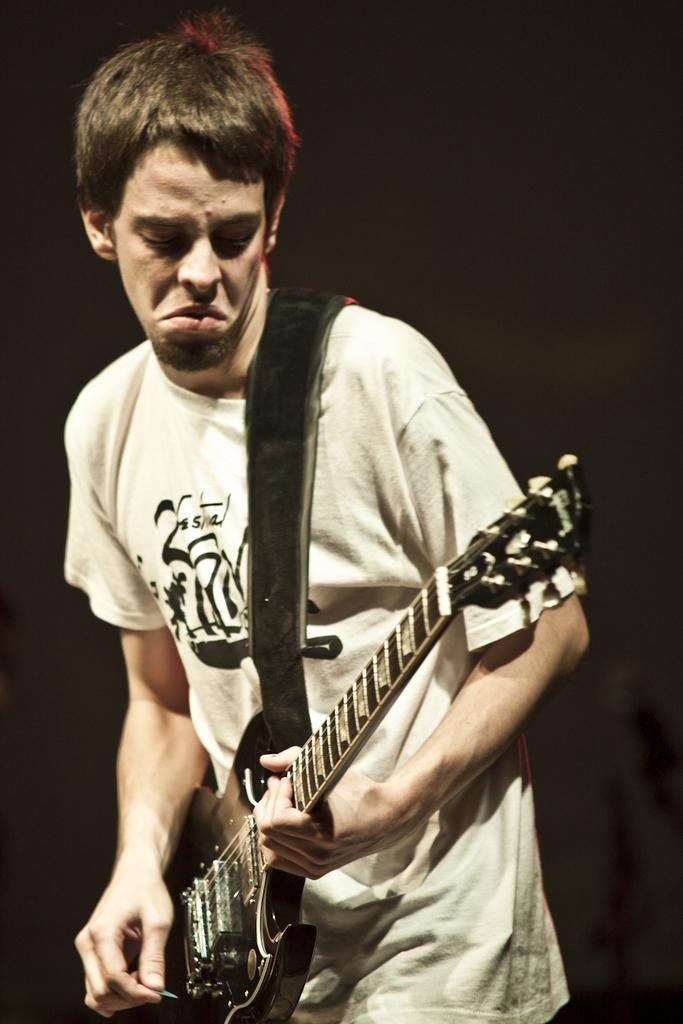What is the main subject of the image? There is a person in the image. What is the person doing in the image? The person is standing in the image. What object is the person holding in the image? The person is holding a guitar in the image. What type of toe is visible in the image? There is no toe visible in the image; it features a person standing and holding a guitar. What is being served for dinner in the image? There is no reference to dinner or any food in the image. 